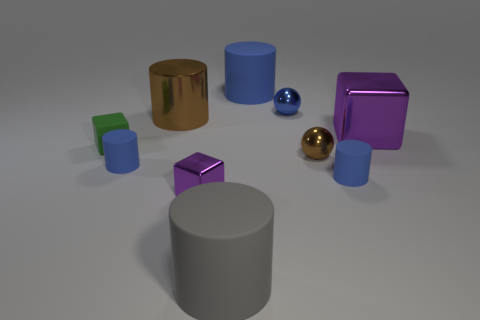Subtract all cyan balls. How many blue cylinders are left? 3 Subtract 2 cylinders. How many cylinders are left? 3 Subtract all green cylinders. Subtract all brown spheres. How many cylinders are left? 5 Subtract all cubes. How many objects are left? 7 Add 8 big matte cylinders. How many big matte cylinders exist? 10 Subtract 1 brown balls. How many objects are left? 9 Subtract all tiny green blocks. Subtract all small spheres. How many objects are left? 7 Add 6 big gray rubber things. How many big gray rubber things are left? 7 